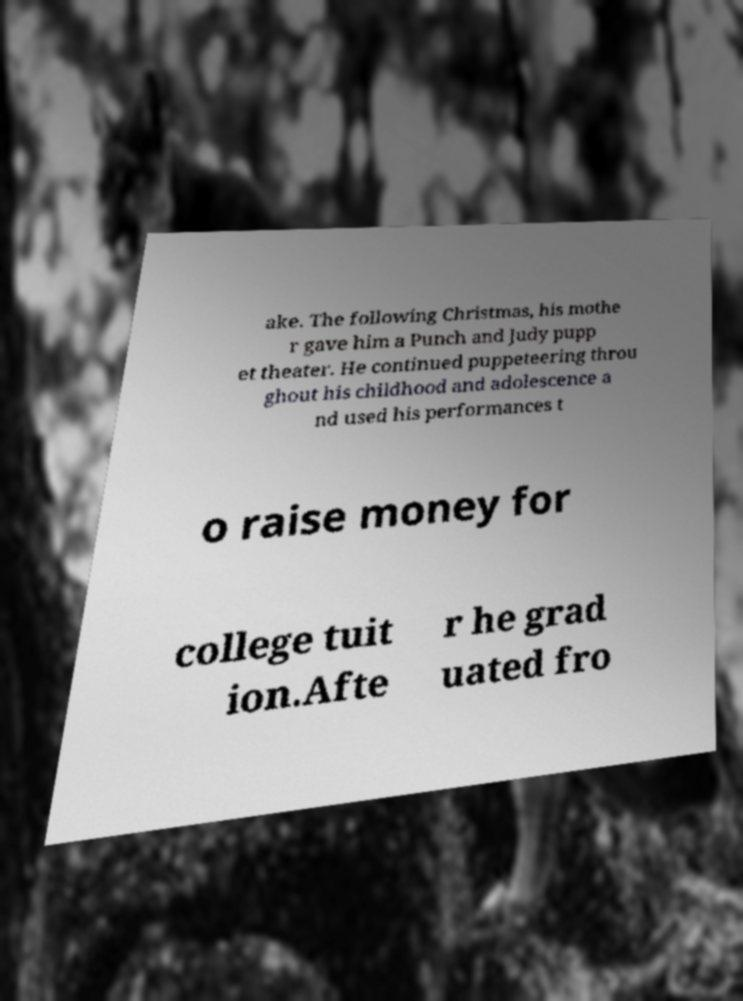Could you assist in decoding the text presented in this image and type it out clearly? ake. The following Christmas, his mothe r gave him a Punch and Judy pupp et theater. He continued puppeteering throu ghout his childhood and adolescence a nd used his performances t o raise money for college tuit ion.Afte r he grad uated fro 